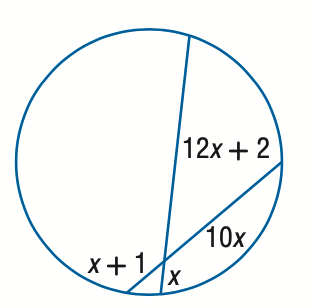Answer the mathemtical geometry problem and directly provide the correct option letter.
Question: Find x. Assume that segments that appear to be tangent are tangent.
Choices: A: 2 B: 3 C: 4 D: 5 C 